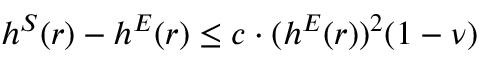Convert formula to latex. <formula><loc_0><loc_0><loc_500><loc_500>h ^ { S } ( r ) - h ^ { E } ( r ) \leq c \cdot ( h ^ { E } ( r ) ) ^ { 2 } ( 1 - \nu )</formula> 